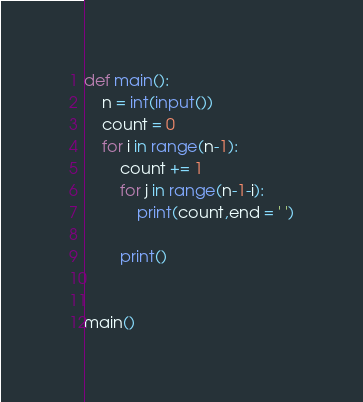<code> <loc_0><loc_0><loc_500><loc_500><_Python_>def main():
    n = int(input())
    count = 0
    for i in range(n-1):
        count += 1
        for j in range(n-1-i):
            print(count,end = ' ')

        print()


main()
</code> 